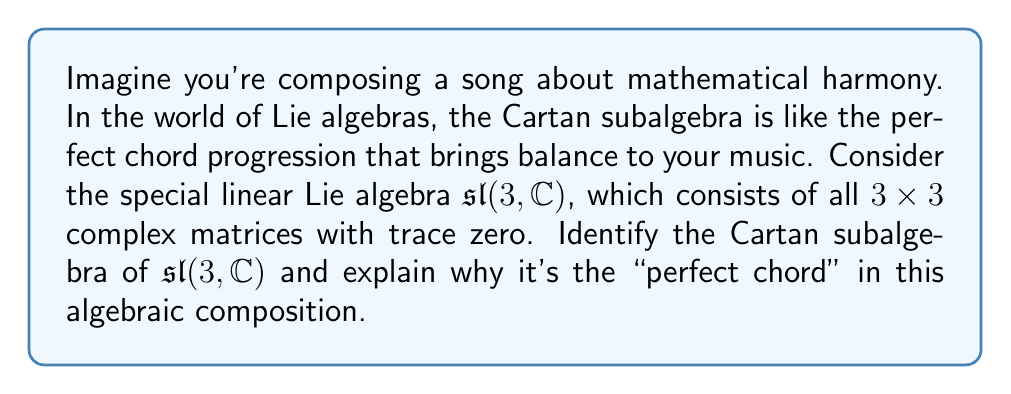Show me your answer to this math problem. To find the Cartan subalgebra of $\mathfrak{sl}(3, \mathbb{C})$, we need to follow these steps:

1) Recall that a Cartan subalgebra is a maximal abelian subalgebra consisting of semisimple elements.

2) In $\mathfrak{sl}(3, \mathbb{C})$, the semisimple elements are the diagonalizable matrices with trace zero.

3) The largest set of mutually commuting diagonalizable matrices in $\mathfrak{sl}(3, \mathbb{C})$ is the set of all diagonal matrices with trace zero.

4) We can represent a general element of this set as:

   $$\begin{pmatrix}
   a & 0 & 0 \\
   0 & b & 0 \\
   0 & 0 & c
   \end{pmatrix}$$

   where $a + b + c = 0$ to ensure the trace is zero.

5) This set forms a 2-dimensional subspace of $\mathfrak{sl}(3, \mathbb{C})$, as we have two free parameters (say, $a$ and $b$) with the third determined by the trace condition.

6) We can express this subspace using a basis. One possible basis is:

   $$h_1 = \begin{pmatrix}
   1 & 0 & 0 \\
   0 & -1 & 0 \\
   0 & 0 & 0
   \end{pmatrix}, \quad
   h_2 = \begin{pmatrix}
   1 & 0 & 0 \\
   0 & 0 & 0 \\
   0 & 0 & -1
   \end{pmatrix}$$

7) Any element in the Cartan subalgebra can be written as a linear combination of these basis elements: $ah_1 + bh_2$ where $a, b \in \mathbb{C}$.

This subspace is indeed the Cartan subalgebra because:
- It's abelian (all elements commute with each other)
- It consists of semisimple elements (all diagonal matrices are diagonalizable)
- It's maximal (adding any non-diagonal matrix would make it non-abelian)

In the context of our musical analogy, this Cartan subalgebra represents the "perfect chord" because it provides a fundamental structure (like a tonic chord) from which we can build more complex harmonies (the rest of the Lie algebra).
Answer: The Cartan subalgebra of $\mathfrak{sl}(3, \mathbb{C})$ is the 2-dimensional subspace of diagonal matrices with trace zero, which can be represented as:

$$\left\{a\begin{pmatrix}
1 & 0 & 0 \\
0 & -1 & 0 \\
0 & 0 & 0
\end{pmatrix} + b\begin{pmatrix}
1 & 0 & 0 \\
0 & 0 & 0 \\
0 & 0 & -1
\end{pmatrix} : a, b \in \mathbb{C}\right\}$$ 